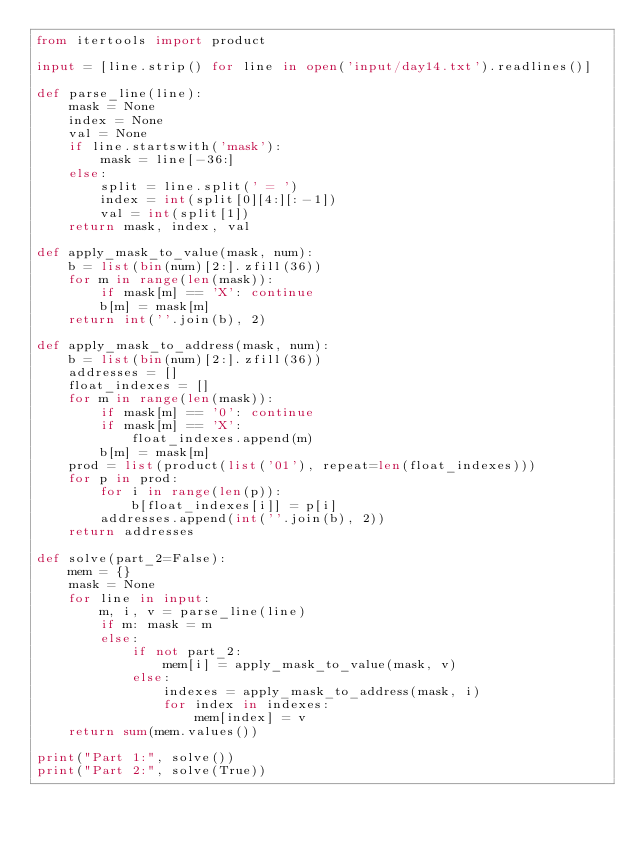Convert code to text. <code><loc_0><loc_0><loc_500><loc_500><_Python_>from itertools import product

input = [line.strip() for line in open('input/day14.txt').readlines()]

def parse_line(line):
    mask = None
    index = None
    val = None
    if line.startswith('mask'):
        mask = line[-36:]
    else:
        split = line.split(' = ')
        index = int(split[0][4:][:-1])
        val = int(split[1])
    return mask, index, val

def apply_mask_to_value(mask, num):
    b = list(bin(num)[2:].zfill(36))
    for m in range(len(mask)):
        if mask[m] == 'X': continue
        b[m] = mask[m]
    return int(''.join(b), 2)

def apply_mask_to_address(mask, num):
    b = list(bin(num)[2:].zfill(36))
    addresses = []
    float_indexes = []
    for m in range(len(mask)):
        if mask[m] == '0': continue
        if mask[m] == 'X':
            float_indexes.append(m)
        b[m] = mask[m]
    prod = list(product(list('01'), repeat=len(float_indexes)))
    for p in prod:
        for i in range(len(p)):
            b[float_indexes[i]] = p[i]
        addresses.append(int(''.join(b), 2))
    return addresses

def solve(part_2=False):
    mem = {}
    mask = None
    for line in input:
        m, i, v = parse_line(line)
        if m: mask = m
        else:
            if not part_2:
                mem[i] = apply_mask_to_value(mask, v)
            else:
                indexes = apply_mask_to_address(mask, i)
                for index in indexes:
                    mem[index] = v
    return sum(mem.values())

print("Part 1:", solve())
print("Part 2:", solve(True))

</code> 